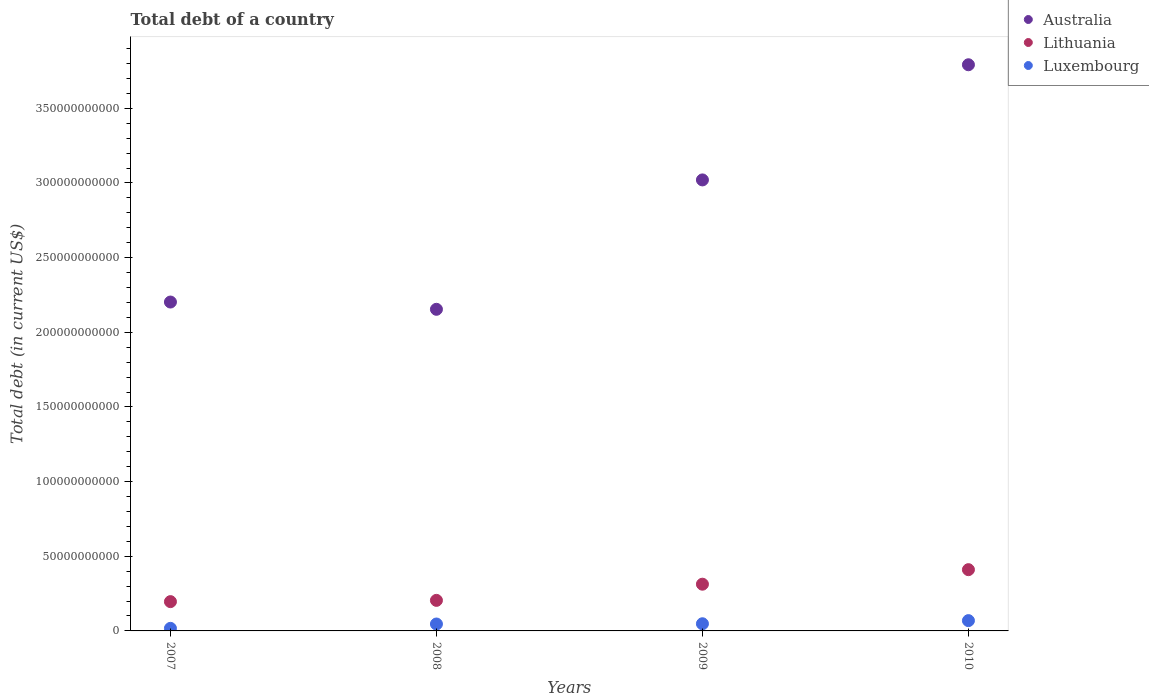Is the number of dotlines equal to the number of legend labels?
Provide a short and direct response. Yes. What is the debt in Lithuania in 2010?
Your answer should be compact. 4.10e+1. Across all years, what is the maximum debt in Australia?
Give a very brief answer. 3.79e+11. Across all years, what is the minimum debt in Australia?
Offer a very short reply. 2.15e+11. In which year was the debt in Luxembourg maximum?
Ensure brevity in your answer.  2010. What is the total debt in Luxembourg in the graph?
Your answer should be compact. 1.80e+1. What is the difference between the debt in Lithuania in 2009 and that in 2010?
Your answer should be compact. -9.73e+09. What is the difference between the debt in Luxembourg in 2009 and the debt in Lithuania in 2010?
Your answer should be very brief. -3.62e+1. What is the average debt in Luxembourg per year?
Your answer should be very brief. 4.51e+09. In the year 2010, what is the difference between the debt in Lithuania and debt in Australia?
Make the answer very short. -3.38e+11. In how many years, is the debt in Australia greater than 180000000000 US$?
Offer a very short reply. 4. What is the ratio of the debt in Australia in 2007 to that in 2009?
Your response must be concise. 0.73. Is the debt in Luxembourg in 2008 less than that in 2009?
Provide a short and direct response. Yes. Is the difference between the debt in Lithuania in 2007 and 2010 greater than the difference between the debt in Australia in 2007 and 2010?
Offer a very short reply. Yes. What is the difference between the highest and the second highest debt in Australia?
Provide a short and direct response. 7.71e+1. What is the difference between the highest and the lowest debt in Luxembourg?
Your answer should be very brief. 5.17e+09. In how many years, is the debt in Lithuania greater than the average debt in Lithuania taken over all years?
Give a very brief answer. 2. Is the debt in Luxembourg strictly greater than the debt in Australia over the years?
Provide a short and direct response. No. Is the debt in Australia strictly less than the debt in Lithuania over the years?
Offer a terse response. No. How many dotlines are there?
Your answer should be very brief. 3. How many years are there in the graph?
Make the answer very short. 4. Does the graph contain grids?
Offer a very short reply. No. Where does the legend appear in the graph?
Your answer should be compact. Top right. What is the title of the graph?
Your answer should be very brief. Total debt of a country. Does "Jordan" appear as one of the legend labels in the graph?
Provide a short and direct response. No. What is the label or title of the Y-axis?
Offer a very short reply. Total debt (in current US$). What is the Total debt (in current US$) of Australia in 2007?
Provide a succinct answer. 2.20e+11. What is the Total debt (in current US$) in Lithuania in 2007?
Offer a very short reply. 1.96e+1. What is the Total debt (in current US$) in Luxembourg in 2007?
Provide a succinct answer. 1.72e+09. What is the Total debt (in current US$) of Australia in 2008?
Provide a succinct answer. 2.15e+11. What is the Total debt (in current US$) of Lithuania in 2008?
Your answer should be compact. 2.05e+1. What is the Total debt (in current US$) of Luxembourg in 2008?
Ensure brevity in your answer.  4.63e+09. What is the Total debt (in current US$) of Australia in 2009?
Keep it short and to the point. 3.02e+11. What is the Total debt (in current US$) of Lithuania in 2009?
Give a very brief answer. 3.13e+1. What is the Total debt (in current US$) of Luxembourg in 2009?
Provide a short and direct response. 4.80e+09. What is the Total debt (in current US$) in Australia in 2010?
Offer a terse response. 3.79e+11. What is the Total debt (in current US$) of Lithuania in 2010?
Offer a terse response. 4.10e+1. What is the Total debt (in current US$) in Luxembourg in 2010?
Your answer should be very brief. 6.89e+09. Across all years, what is the maximum Total debt (in current US$) in Australia?
Provide a short and direct response. 3.79e+11. Across all years, what is the maximum Total debt (in current US$) of Lithuania?
Your response must be concise. 4.10e+1. Across all years, what is the maximum Total debt (in current US$) in Luxembourg?
Offer a very short reply. 6.89e+09. Across all years, what is the minimum Total debt (in current US$) in Australia?
Make the answer very short. 2.15e+11. Across all years, what is the minimum Total debt (in current US$) of Lithuania?
Provide a short and direct response. 1.96e+1. Across all years, what is the minimum Total debt (in current US$) of Luxembourg?
Provide a short and direct response. 1.72e+09. What is the total Total debt (in current US$) in Australia in the graph?
Make the answer very short. 1.12e+12. What is the total Total debt (in current US$) of Lithuania in the graph?
Provide a succinct answer. 1.12e+11. What is the total Total debt (in current US$) in Luxembourg in the graph?
Offer a very short reply. 1.80e+1. What is the difference between the Total debt (in current US$) in Australia in 2007 and that in 2008?
Keep it short and to the point. 4.87e+09. What is the difference between the Total debt (in current US$) in Lithuania in 2007 and that in 2008?
Make the answer very short. -8.50e+08. What is the difference between the Total debt (in current US$) in Luxembourg in 2007 and that in 2008?
Give a very brief answer. -2.91e+09. What is the difference between the Total debt (in current US$) of Australia in 2007 and that in 2009?
Keep it short and to the point. -8.18e+1. What is the difference between the Total debt (in current US$) in Lithuania in 2007 and that in 2009?
Keep it short and to the point. -1.17e+1. What is the difference between the Total debt (in current US$) in Luxembourg in 2007 and that in 2009?
Give a very brief answer. -3.08e+09. What is the difference between the Total debt (in current US$) in Australia in 2007 and that in 2010?
Offer a terse response. -1.59e+11. What is the difference between the Total debt (in current US$) in Lithuania in 2007 and that in 2010?
Offer a very short reply. -2.14e+1. What is the difference between the Total debt (in current US$) of Luxembourg in 2007 and that in 2010?
Offer a terse response. -5.17e+09. What is the difference between the Total debt (in current US$) in Australia in 2008 and that in 2009?
Provide a succinct answer. -8.67e+1. What is the difference between the Total debt (in current US$) in Lithuania in 2008 and that in 2009?
Offer a terse response. -1.08e+1. What is the difference between the Total debt (in current US$) in Luxembourg in 2008 and that in 2009?
Offer a terse response. -1.70e+08. What is the difference between the Total debt (in current US$) in Australia in 2008 and that in 2010?
Offer a terse response. -1.64e+11. What is the difference between the Total debt (in current US$) in Lithuania in 2008 and that in 2010?
Offer a terse response. -2.06e+1. What is the difference between the Total debt (in current US$) of Luxembourg in 2008 and that in 2010?
Your answer should be very brief. -2.27e+09. What is the difference between the Total debt (in current US$) of Australia in 2009 and that in 2010?
Make the answer very short. -7.71e+1. What is the difference between the Total debt (in current US$) in Lithuania in 2009 and that in 2010?
Provide a succinct answer. -9.73e+09. What is the difference between the Total debt (in current US$) in Luxembourg in 2009 and that in 2010?
Keep it short and to the point. -2.10e+09. What is the difference between the Total debt (in current US$) in Australia in 2007 and the Total debt (in current US$) in Lithuania in 2008?
Provide a succinct answer. 2.00e+11. What is the difference between the Total debt (in current US$) in Australia in 2007 and the Total debt (in current US$) in Luxembourg in 2008?
Keep it short and to the point. 2.16e+11. What is the difference between the Total debt (in current US$) in Lithuania in 2007 and the Total debt (in current US$) in Luxembourg in 2008?
Give a very brief answer. 1.50e+1. What is the difference between the Total debt (in current US$) of Australia in 2007 and the Total debt (in current US$) of Lithuania in 2009?
Your response must be concise. 1.89e+11. What is the difference between the Total debt (in current US$) in Australia in 2007 and the Total debt (in current US$) in Luxembourg in 2009?
Keep it short and to the point. 2.15e+11. What is the difference between the Total debt (in current US$) of Lithuania in 2007 and the Total debt (in current US$) of Luxembourg in 2009?
Offer a very short reply. 1.48e+1. What is the difference between the Total debt (in current US$) of Australia in 2007 and the Total debt (in current US$) of Lithuania in 2010?
Provide a short and direct response. 1.79e+11. What is the difference between the Total debt (in current US$) of Australia in 2007 and the Total debt (in current US$) of Luxembourg in 2010?
Keep it short and to the point. 2.13e+11. What is the difference between the Total debt (in current US$) of Lithuania in 2007 and the Total debt (in current US$) of Luxembourg in 2010?
Give a very brief answer. 1.27e+1. What is the difference between the Total debt (in current US$) of Australia in 2008 and the Total debt (in current US$) of Lithuania in 2009?
Make the answer very short. 1.84e+11. What is the difference between the Total debt (in current US$) of Australia in 2008 and the Total debt (in current US$) of Luxembourg in 2009?
Provide a short and direct response. 2.11e+11. What is the difference between the Total debt (in current US$) in Lithuania in 2008 and the Total debt (in current US$) in Luxembourg in 2009?
Keep it short and to the point. 1.57e+1. What is the difference between the Total debt (in current US$) of Australia in 2008 and the Total debt (in current US$) of Lithuania in 2010?
Ensure brevity in your answer.  1.74e+11. What is the difference between the Total debt (in current US$) in Australia in 2008 and the Total debt (in current US$) in Luxembourg in 2010?
Keep it short and to the point. 2.09e+11. What is the difference between the Total debt (in current US$) in Lithuania in 2008 and the Total debt (in current US$) in Luxembourg in 2010?
Keep it short and to the point. 1.36e+1. What is the difference between the Total debt (in current US$) in Australia in 2009 and the Total debt (in current US$) in Lithuania in 2010?
Your response must be concise. 2.61e+11. What is the difference between the Total debt (in current US$) in Australia in 2009 and the Total debt (in current US$) in Luxembourg in 2010?
Provide a succinct answer. 2.95e+11. What is the difference between the Total debt (in current US$) of Lithuania in 2009 and the Total debt (in current US$) of Luxembourg in 2010?
Provide a succinct answer. 2.44e+1. What is the average Total debt (in current US$) of Australia per year?
Keep it short and to the point. 2.79e+11. What is the average Total debt (in current US$) in Lithuania per year?
Provide a succinct answer. 2.81e+1. What is the average Total debt (in current US$) of Luxembourg per year?
Make the answer very short. 4.51e+09. In the year 2007, what is the difference between the Total debt (in current US$) in Australia and Total debt (in current US$) in Lithuania?
Keep it short and to the point. 2.01e+11. In the year 2007, what is the difference between the Total debt (in current US$) in Australia and Total debt (in current US$) in Luxembourg?
Offer a terse response. 2.19e+11. In the year 2007, what is the difference between the Total debt (in current US$) in Lithuania and Total debt (in current US$) in Luxembourg?
Provide a short and direct response. 1.79e+1. In the year 2008, what is the difference between the Total debt (in current US$) of Australia and Total debt (in current US$) of Lithuania?
Your answer should be compact. 1.95e+11. In the year 2008, what is the difference between the Total debt (in current US$) in Australia and Total debt (in current US$) in Luxembourg?
Your response must be concise. 2.11e+11. In the year 2008, what is the difference between the Total debt (in current US$) of Lithuania and Total debt (in current US$) of Luxembourg?
Your response must be concise. 1.58e+1. In the year 2009, what is the difference between the Total debt (in current US$) in Australia and Total debt (in current US$) in Lithuania?
Keep it short and to the point. 2.71e+11. In the year 2009, what is the difference between the Total debt (in current US$) in Australia and Total debt (in current US$) in Luxembourg?
Your answer should be compact. 2.97e+11. In the year 2009, what is the difference between the Total debt (in current US$) of Lithuania and Total debt (in current US$) of Luxembourg?
Provide a succinct answer. 2.65e+1. In the year 2010, what is the difference between the Total debt (in current US$) of Australia and Total debt (in current US$) of Lithuania?
Offer a terse response. 3.38e+11. In the year 2010, what is the difference between the Total debt (in current US$) in Australia and Total debt (in current US$) in Luxembourg?
Offer a very short reply. 3.72e+11. In the year 2010, what is the difference between the Total debt (in current US$) of Lithuania and Total debt (in current US$) of Luxembourg?
Your answer should be very brief. 3.41e+1. What is the ratio of the Total debt (in current US$) in Australia in 2007 to that in 2008?
Your answer should be very brief. 1.02. What is the ratio of the Total debt (in current US$) of Lithuania in 2007 to that in 2008?
Make the answer very short. 0.96. What is the ratio of the Total debt (in current US$) in Luxembourg in 2007 to that in 2008?
Provide a short and direct response. 0.37. What is the ratio of the Total debt (in current US$) in Australia in 2007 to that in 2009?
Offer a terse response. 0.73. What is the ratio of the Total debt (in current US$) of Lithuania in 2007 to that in 2009?
Provide a succinct answer. 0.63. What is the ratio of the Total debt (in current US$) of Luxembourg in 2007 to that in 2009?
Offer a very short reply. 0.36. What is the ratio of the Total debt (in current US$) in Australia in 2007 to that in 2010?
Offer a terse response. 0.58. What is the ratio of the Total debt (in current US$) in Lithuania in 2007 to that in 2010?
Ensure brevity in your answer.  0.48. What is the ratio of the Total debt (in current US$) of Luxembourg in 2007 to that in 2010?
Your response must be concise. 0.25. What is the ratio of the Total debt (in current US$) of Australia in 2008 to that in 2009?
Ensure brevity in your answer.  0.71. What is the ratio of the Total debt (in current US$) of Lithuania in 2008 to that in 2009?
Make the answer very short. 0.65. What is the ratio of the Total debt (in current US$) of Luxembourg in 2008 to that in 2009?
Your answer should be compact. 0.96. What is the ratio of the Total debt (in current US$) in Australia in 2008 to that in 2010?
Provide a succinct answer. 0.57. What is the ratio of the Total debt (in current US$) in Lithuania in 2008 to that in 2010?
Your answer should be very brief. 0.5. What is the ratio of the Total debt (in current US$) in Luxembourg in 2008 to that in 2010?
Provide a short and direct response. 0.67. What is the ratio of the Total debt (in current US$) of Australia in 2009 to that in 2010?
Offer a very short reply. 0.8. What is the ratio of the Total debt (in current US$) of Lithuania in 2009 to that in 2010?
Provide a short and direct response. 0.76. What is the ratio of the Total debt (in current US$) of Luxembourg in 2009 to that in 2010?
Give a very brief answer. 0.7. What is the difference between the highest and the second highest Total debt (in current US$) of Australia?
Offer a terse response. 7.71e+1. What is the difference between the highest and the second highest Total debt (in current US$) of Lithuania?
Give a very brief answer. 9.73e+09. What is the difference between the highest and the second highest Total debt (in current US$) in Luxembourg?
Ensure brevity in your answer.  2.10e+09. What is the difference between the highest and the lowest Total debt (in current US$) of Australia?
Ensure brevity in your answer.  1.64e+11. What is the difference between the highest and the lowest Total debt (in current US$) in Lithuania?
Provide a succinct answer. 2.14e+1. What is the difference between the highest and the lowest Total debt (in current US$) in Luxembourg?
Your response must be concise. 5.17e+09. 